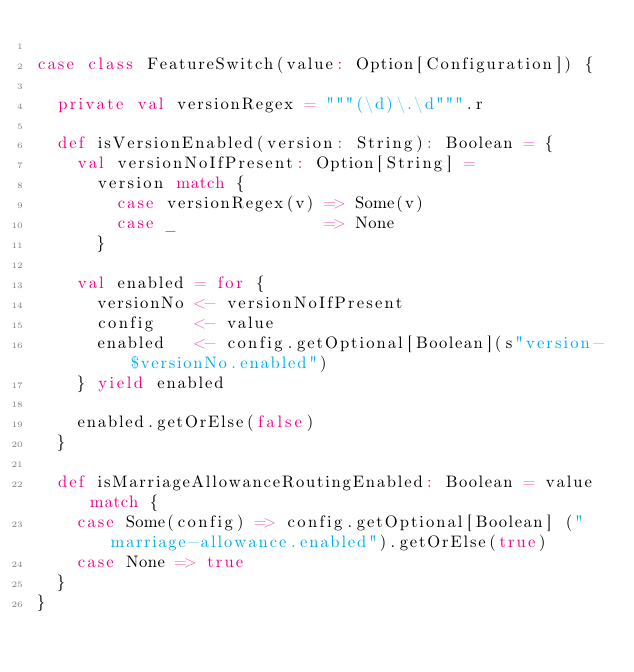Convert code to text. <code><loc_0><loc_0><loc_500><loc_500><_Scala_>
case class FeatureSwitch(value: Option[Configuration]) {

  private val versionRegex = """(\d)\.\d""".r

  def isVersionEnabled(version: String): Boolean = {
    val versionNoIfPresent: Option[String] =
      version match {
        case versionRegex(v) => Some(v)
        case _               => None
      }

    val enabled = for {
      versionNo <- versionNoIfPresent
      config    <- value
      enabled   <- config.getOptional[Boolean](s"version-$versionNo.enabled")
    } yield enabled

    enabled.getOrElse(false)
  }

  def isMarriageAllowanceRoutingEnabled: Boolean = value match {
    case Some(config) => config.getOptional[Boolean] ("marriage-allowance.enabled").getOrElse(true)
    case None => true
  }
}
</code> 